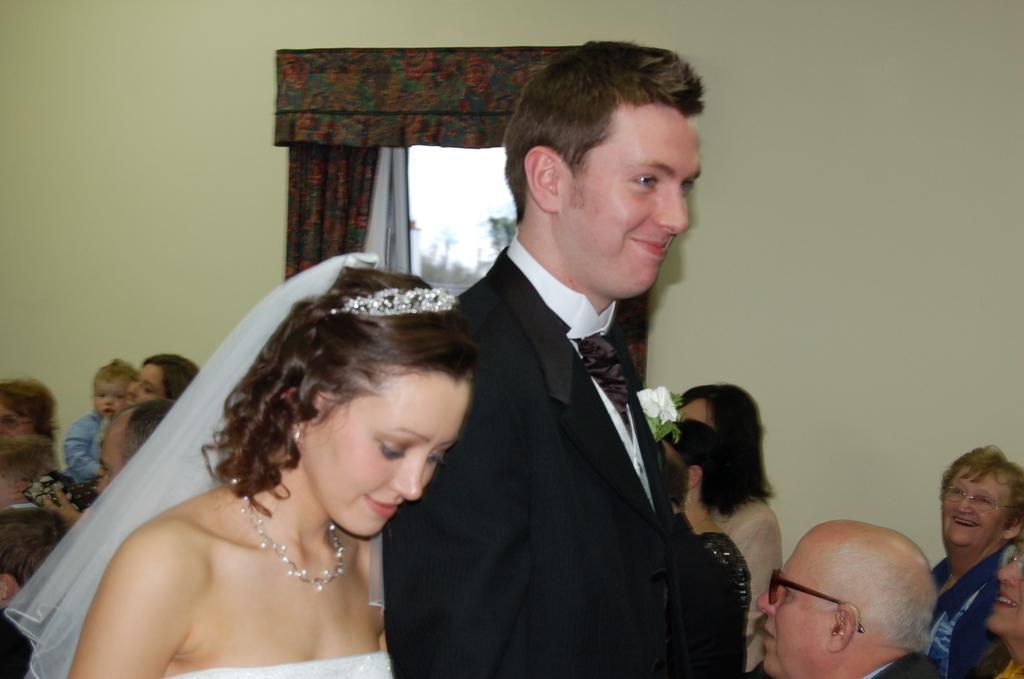Can you describe this image briefly? In the image there is a bride couple standing in the middle and behind there are many people sitting on chairs in front of window with curtains. 